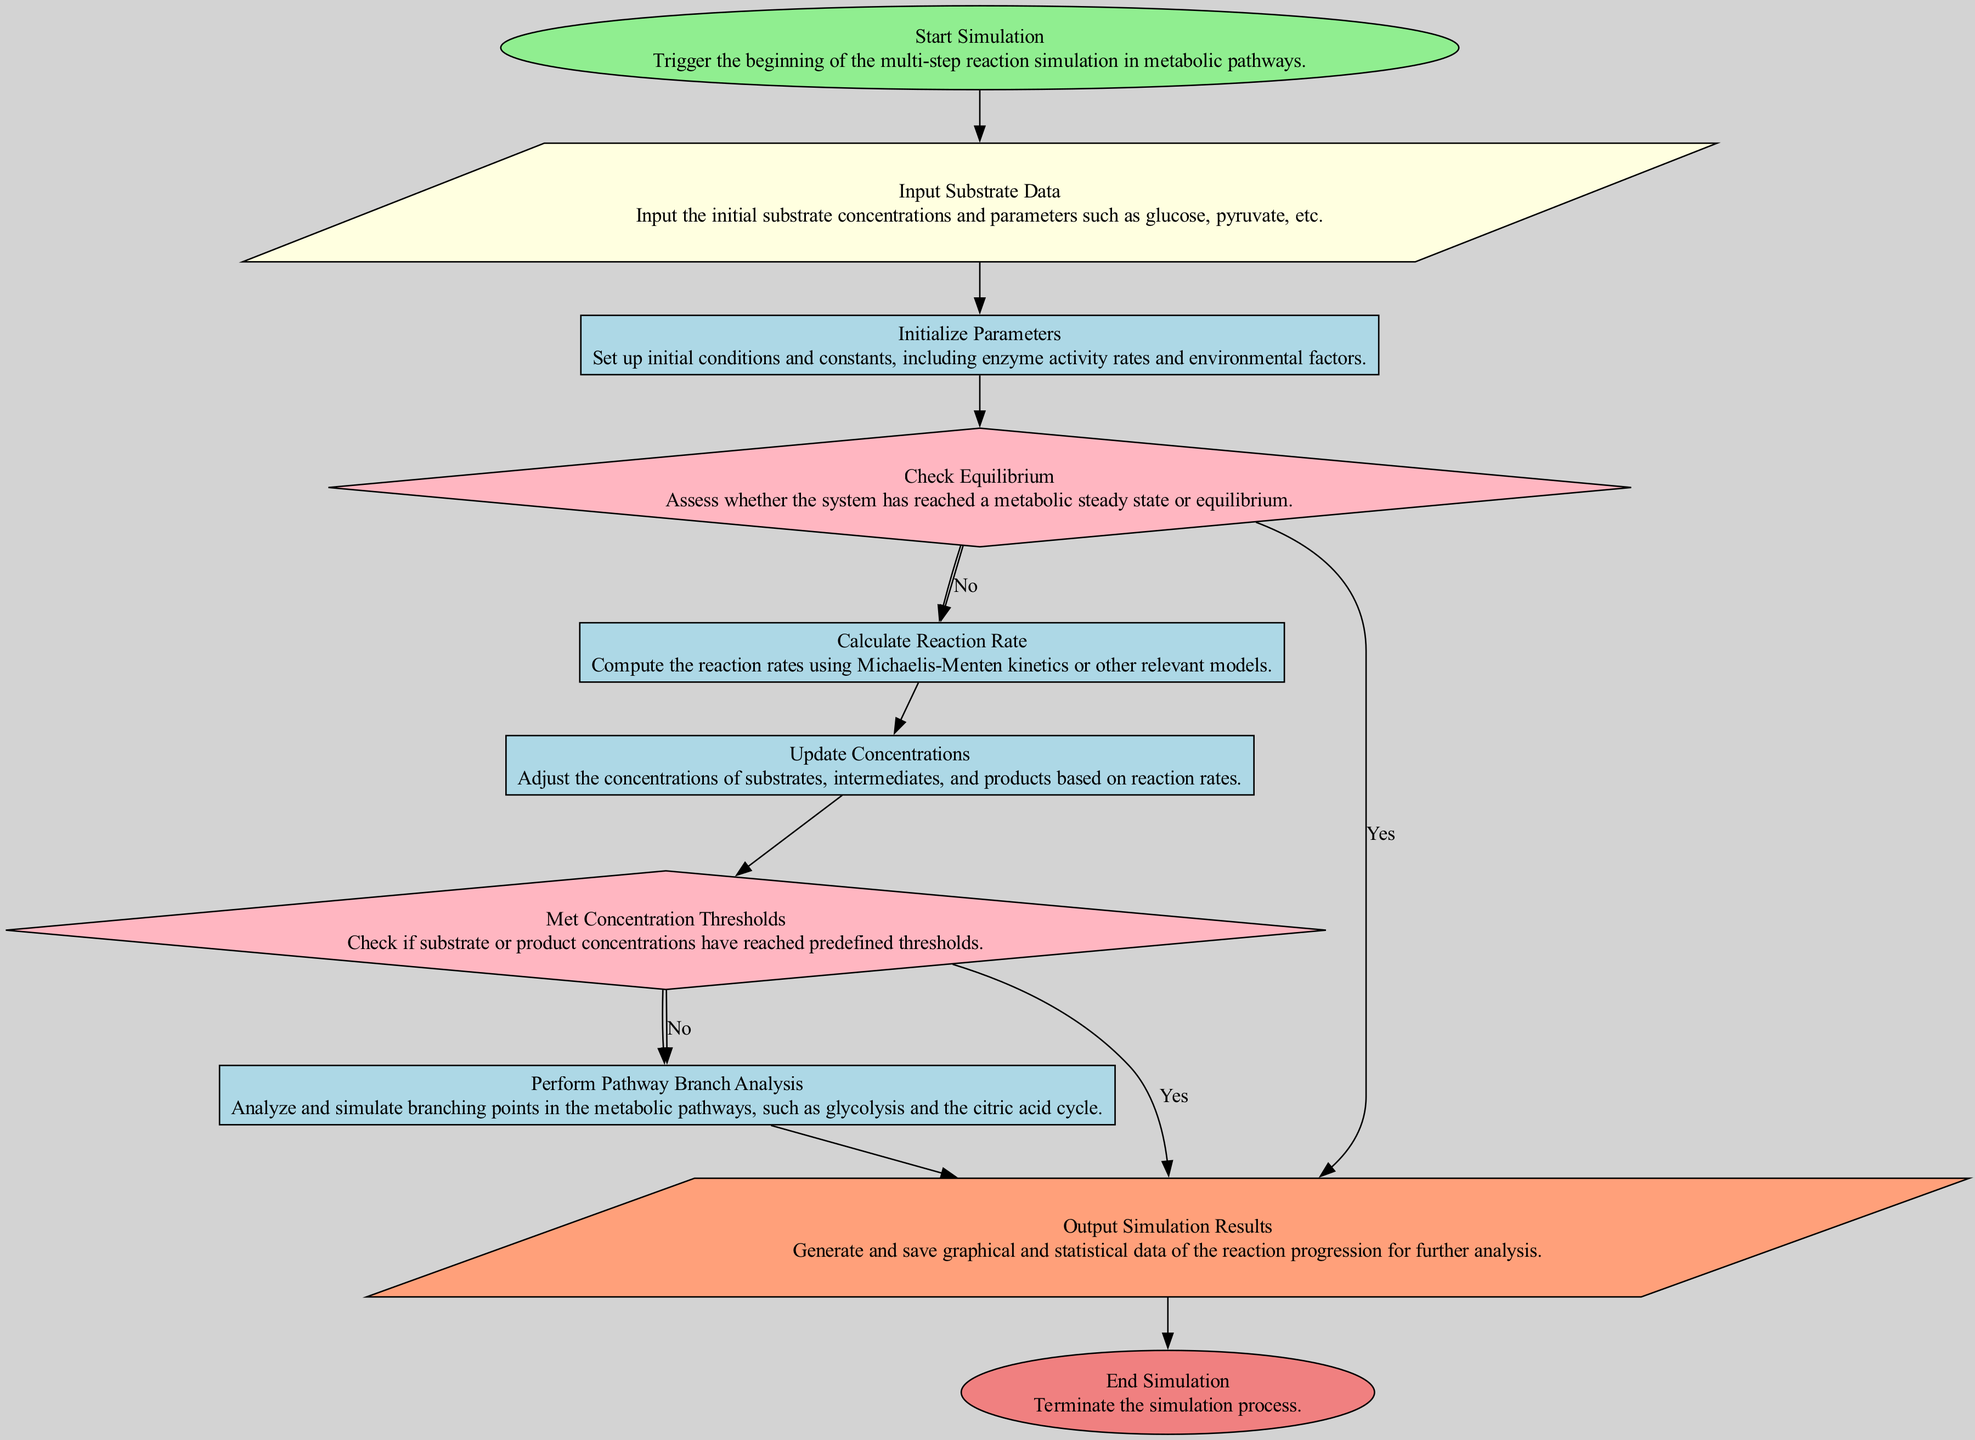What is the first step of the simulation process? The first step in the flowchart is "Start Simulation," which initiates the entire multi-step reaction simulation in metabolic pathways.
Answer: Start Simulation What shape represents the input data stage? The input data stage is represented by a parallelogram shape, which is a common representation for input processes in flowcharts.
Answer: Parallelogram How many decision points are present in the diagram? There are two decision points in the diagram: "Check Equilibrium" and "Met Concentration Thresholds," which evaluate specific conditions during the simulation.
Answer: 2 What happens if equilibrium is reached? If equilibrium is reached, the flowchart indicates that the process will move directly to "Output Simulation Results," skipping the calculation of the reaction rate.
Answer: Output Simulation Results What are the two outcomes if the concentration thresholds are not met? If the concentration thresholds are not met, the process will continue to "Perform Pathway Branch Analysis," and the simulation will not output results at that point.
Answer: Perform Pathway Branch Analysis What node follows "Calculate Reaction Rate"? The node directly following "Calculate Reaction Rate" is "Update Concentrations," indicating that after calculating the reaction rates, the next step is to adjust the concentrations accordingly.
Answer: Update Concentrations Which node leads to the termination of the simulation process? The node that leads to the end of the simulation process is "End Simulation," where the process concludes after generating results.
Answer: End Simulation How many processes are there in the diagram? There are five process nodes in the diagram: "Initialize Parameters," "Calculate Reaction Rate," "Update Concentrations," "Perform Pathway Branch Analysis," and "Output Simulation Results."
Answer: 5 What is the purpose of the "Perform Pathway Branch Analysis" node? The purpose of "Perform Pathway Branch Analysis" is to analyze and simulate branching points in metabolic pathways, such as glycolysis and the citric acid cycle.
Answer: Analyze branching points 